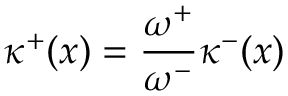<formula> <loc_0><loc_0><loc_500><loc_500>{ \kappa ^ { + } } ( x ) = \frac { \omega ^ { + } } { \omega ^ { - } } \kappa ^ { - } ( x )</formula> 